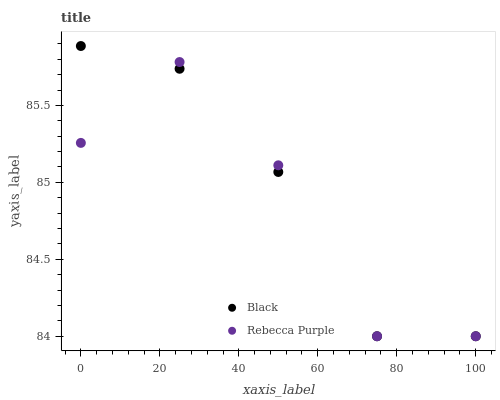Does Rebecca Purple have the minimum area under the curve?
Answer yes or no. Yes. Does Black have the maximum area under the curve?
Answer yes or no. Yes. Does Rebecca Purple have the maximum area under the curve?
Answer yes or no. No. Is Black the smoothest?
Answer yes or no. Yes. Is Rebecca Purple the roughest?
Answer yes or no. Yes. Is Rebecca Purple the smoothest?
Answer yes or no. No. Does Black have the lowest value?
Answer yes or no. Yes. Does Black have the highest value?
Answer yes or no. Yes. Does Rebecca Purple have the highest value?
Answer yes or no. No. Does Black intersect Rebecca Purple?
Answer yes or no. Yes. Is Black less than Rebecca Purple?
Answer yes or no. No. Is Black greater than Rebecca Purple?
Answer yes or no. No. 